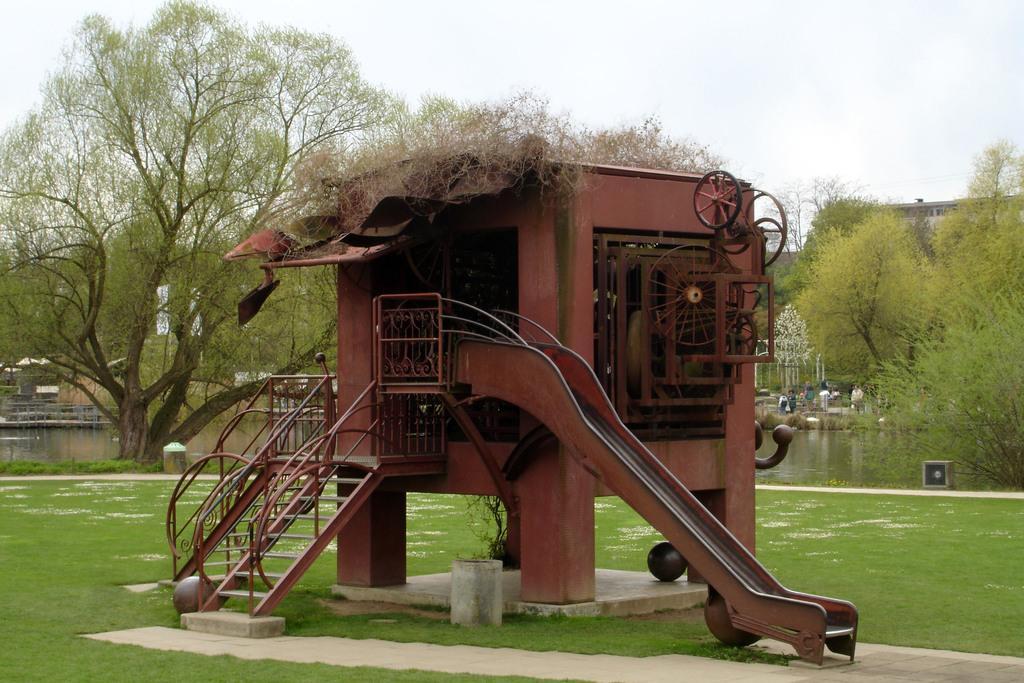Could you give a brief overview of what you see in this image? In this picture we can see grass at the bottom, there are stairs and a slider in the middle, we can see trees, water and a building in the background, we can see the sky at the top of the picture. 